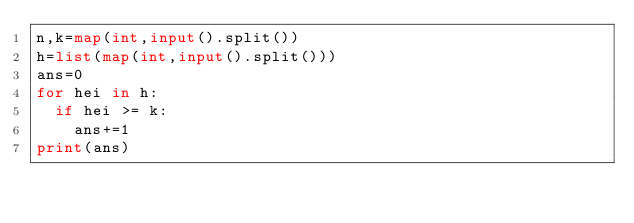Convert code to text. <code><loc_0><loc_0><loc_500><loc_500><_Python_>n,k=map(int,input().split())
h=list(map(int,input().split()))
ans=0
for hei in h:
  if hei >= k:
    ans+=1
print(ans)</code> 